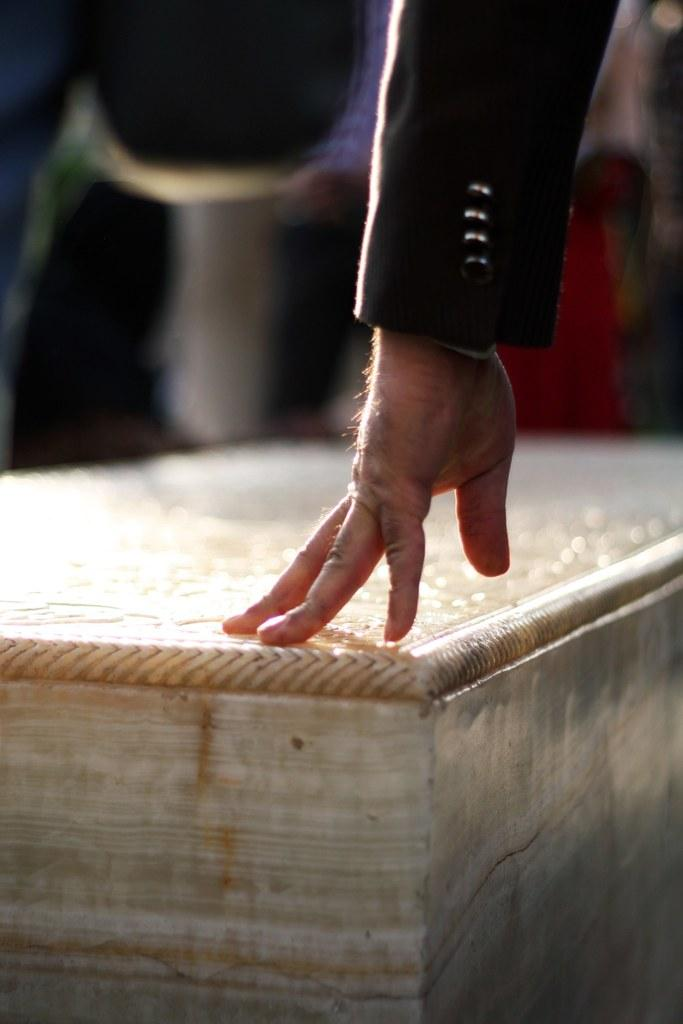What is the main subject of the image? There is a person in the image. What is the person touching or holding in the image? The person's hand is on a wooden object. Can you describe the background of the image? The background of the image is blurry. How many stamps are visible on the tomatoes in the image? There are no stamps or tomatoes present in the image. What is the person doing at the edge of the image? The person's entire body is not visible in the image, so it cannot be determined if they are at the edge or what they might be doing there. 